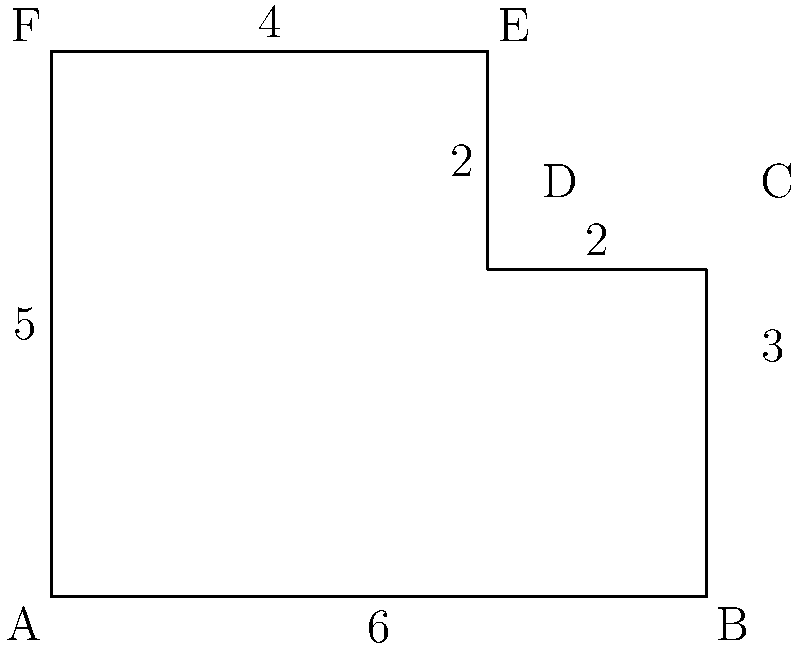You're planning a dinner party and need to buy a tablecloth for your uniquely shaped dining table. To ensure you get the right size, you need to calculate the perimeter of the table. Given the measurements shown in the diagram (in feet), what is the perimeter of your dining table? Let's calculate the perimeter step by step:

1) The perimeter is the sum of all sides of the table.

2) Starting from the bottom-left corner and moving clockwise:
   - Side AB = 6 feet
   - Side BC = 3 feet
   - Side CD = 2 feet
   - Side DE = 2 feet
   - Side EF = 4 feet
   - Side FA = 5 feet

3) Now, let's add all these lengths:
   $$ \text{Perimeter} = 6 + 3 + 2 + 2 + 4 + 5 $$

4) Simplifying:
   $$ \text{Perimeter} = 22 \text{ feet} $$

Therefore, the perimeter of your dining table is 22 feet.
Answer: 22 feet 